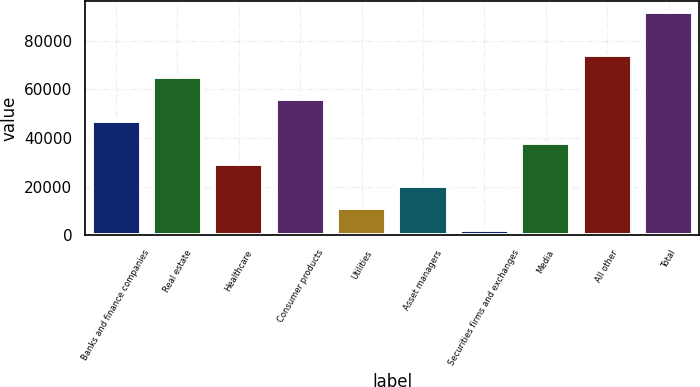Convert chart to OTSL. <chart><loc_0><loc_0><loc_500><loc_500><bar_chart><fcel>Banks and finance companies<fcel>Real estate<fcel>Healthcare<fcel>Consumer products<fcel>Utilities<fcel>Asset managers<fcel>Securities firms and exchanges<fcel>Media<fcel>All other<fcel>Total<nl><fcel>47117<fcel>65052.6<fcel>29181.4<fcel>56084.8<fcel>11245.8<fcel>20213.6<fcel>2278<fcel>38149.2<fcel>74020.4<fcel>91956<nl></chart> 